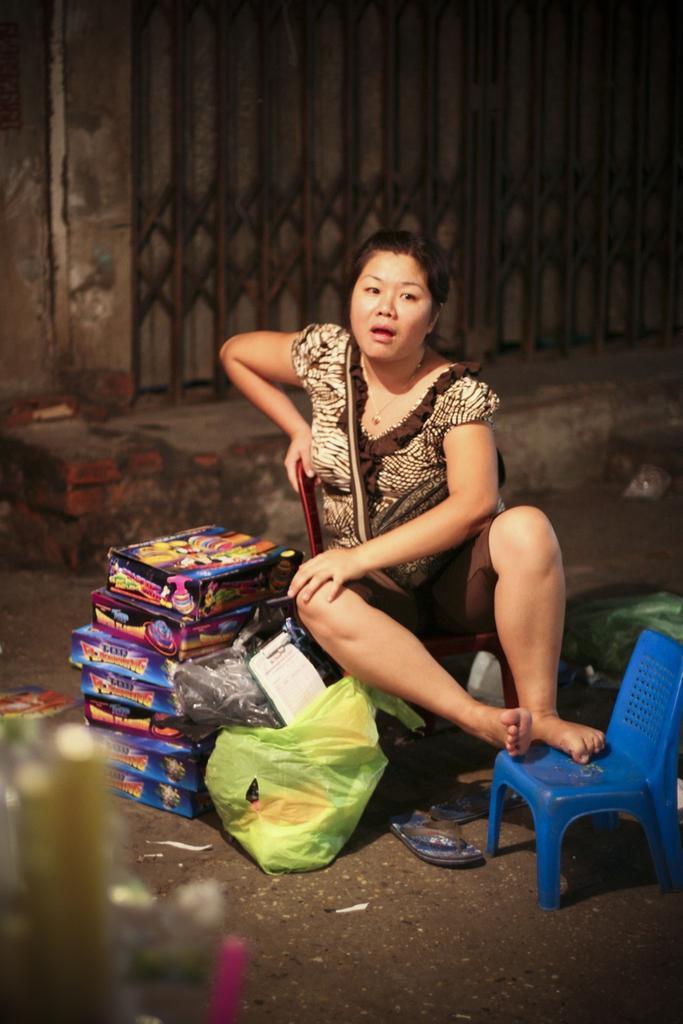How would you summarize this image in a sentence or two? There is a woman sitting on the road placing her legs on a chair. There are some boxes behind her and a cover in front of her. In the background there is a gate and a wall. 